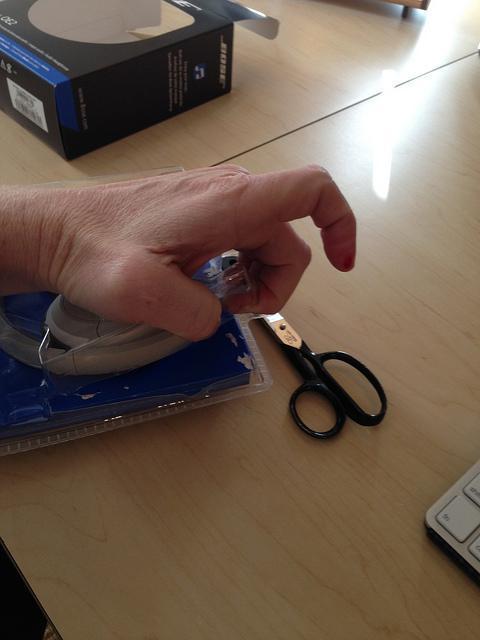How many plugs can you see?
Give a very brief answer. 0. How many people are visible?
Give a very brief answer. 1. 